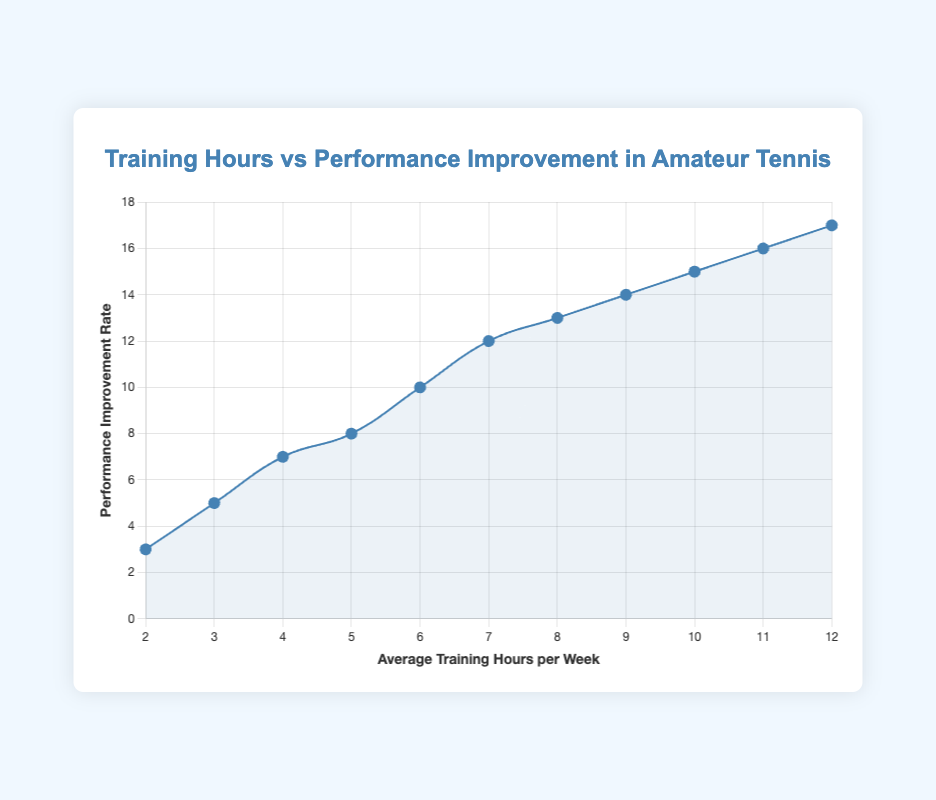What's the average performance improvement rate for players who train 5 or more hours per week? To find the average, first identify the players who train 5 or more hours per week: Ana Martinez (8), Maria Lopez (10), Jorge Ramirez (12), Andrea Navarro (13), Diego Ortiz (14), Sofia Diaz (15), Pablo Suarez (16), Valeria Castro (17). Sum the performance improvement rates: 8 + 10 + 12 + 13 + 14 + 15 + 16 + 17 = 105. Divide by the number of players: 105 / 8 = 13.125
Answer: 13.125 Which player has the highest performance improvement rate? By looking at the figure, the point with the highest improvement rate is Valeria Castro, who has an improvement rate of 17.
Answer: Valeria Castro How much does Maria Lopez's average training hours exceed Juan Pérez's? Maria Lopez trains 6 hours per week, and Juan Pérez trains 2 hours per week. The difference in their training hours is 6 - 2 = 4.
Answer: 4 Is there a player whose training hours match exactly with their performance improvement rate? By inspecting the figure, none of the players have training hours that match their performance improvement rate.
Answer: No What's the total performance improvement rate of players averaging between 6 and 9 training hours per week? Identify the players in this range: Maria Lopez (10), Jorge Ramirez (12), Andrea Navarro (13), Diego Ortiz (14). Sum their improvement rates: 10 + 12 + 13 + 14 = 49.
Answer: 49 